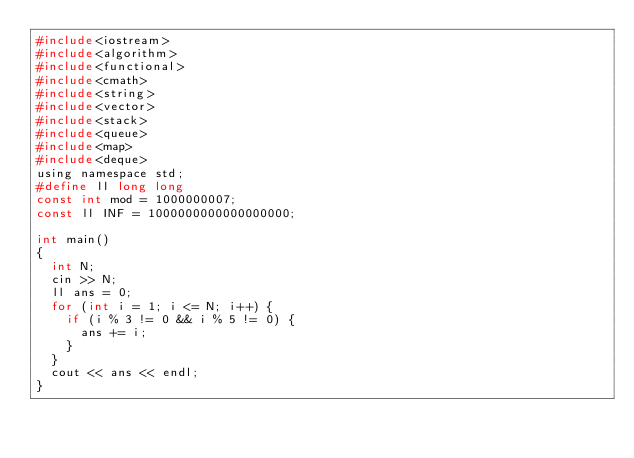<code> <loc_0><loc_0><loc_500><loc_500><_C_>#include<iostream>
#include<algorithm>
#include<functional>
#include<cmath>
#include<string>
#include<vector>
#include<stack>
#include<queue>
#include<map>
#include<deque>
using namespace std;
#define ll long long
const int mod = 1000000007;
const ll INF = 1000000000000000000;

int main()
{
	int N;
	cin >> N;
	ll ans = 0;
	for (int i = 1; i <= N; i++) {
		if (i % 3 != 0 && i % 5 != 0) {
			ans += i;
		}
	}
	cout << ans << endl;
}
</code> 